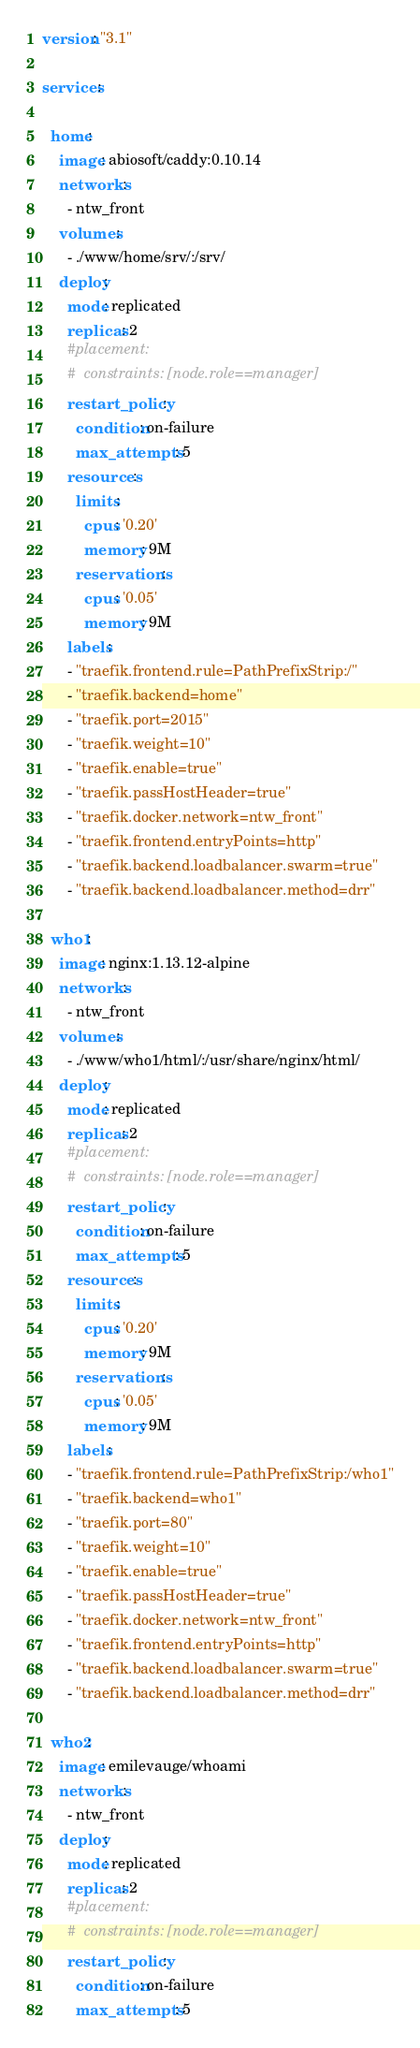<code> <loc_0><loc_0><loc_500><loc_500><_YAML_>version: "3.1"

services:

  home:
    image: abiosoft/caddy:0.10.14
    networks:
      - ntw_front
    volumes:
      - ./www/home/srv/:/srv/
    deploy:
      mode: replicated
      replicas: 2
      #placement:
      #  constraints: [node.role==manager]
      restart_policy:
        condition: on-failure
        max_attempts: 5
      resources:
        limits:
          cpus: '0.20'
          memory: 9M
        reservations:
          cpus: '0.05'
          memory: 9M
      labels:
      - "traefik.frontend.rule=PathPrefixStrip:/"
      - "traefik.backend=home"
      - "traefik.port=2015"
      - "traefik.weight=10"
      - "traefik.enable=true"
      - "traefik.passHostHeader=true"
      - "traefik.docker.network=ntw_front"
      - "traefik.frontend.entryPoints=http"
      - "traefik.backend.loadbalancer.swarm=true"
      - "traefik.backend.loadbalancer.method=drr"

  who1:
    image: nginx:1.13.12-alpine
    networks:
      - ntw_front
    volumes:
      - ./www/who1/html/:/usr/share/nginx/html/
    deploy:
      mode: replicated
      replicas: 2
      #placement:
      #  constraints: [node.role==manager]
      restart_policy:
        condition: on-failure
        max_attempts: 5
      resources:
        limits:
          cpus: '0.20'
          memory: 9M
        reservations:
          cpus: '0.05'
          memory: 9M
      labels:
      - "traefik.frontend.rule=PathPrefixStrip:/who1"
      - "traefik.backend=who1"
      - "traefik.port=80"
      - "traefik.weight=10"
      - "traefik.enable=true"
      - "traefik.passHostHeader=true"
      - "traefik.docker.network=ntw_front"
      - "traefik.frontend.entryPoints=http"
      - "traefik.backend.loadbalancer.swarm=true"
      - "traefik.backend.loadbalancer.method=drr"

  who2:
    image: emilevauge/whoami
    networks:
      - ntw_front
    deploy:
      mode: replicated
      replicas: 2
      #placement:
      #  constraints: [node.role==manager]
      restart_policy:
        condition: on-failure
        max_attempts: 5</code> 